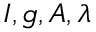<formula> <loc_0><loc_0><loc_500><loc_500>I , g , A , \lambda</formula> 